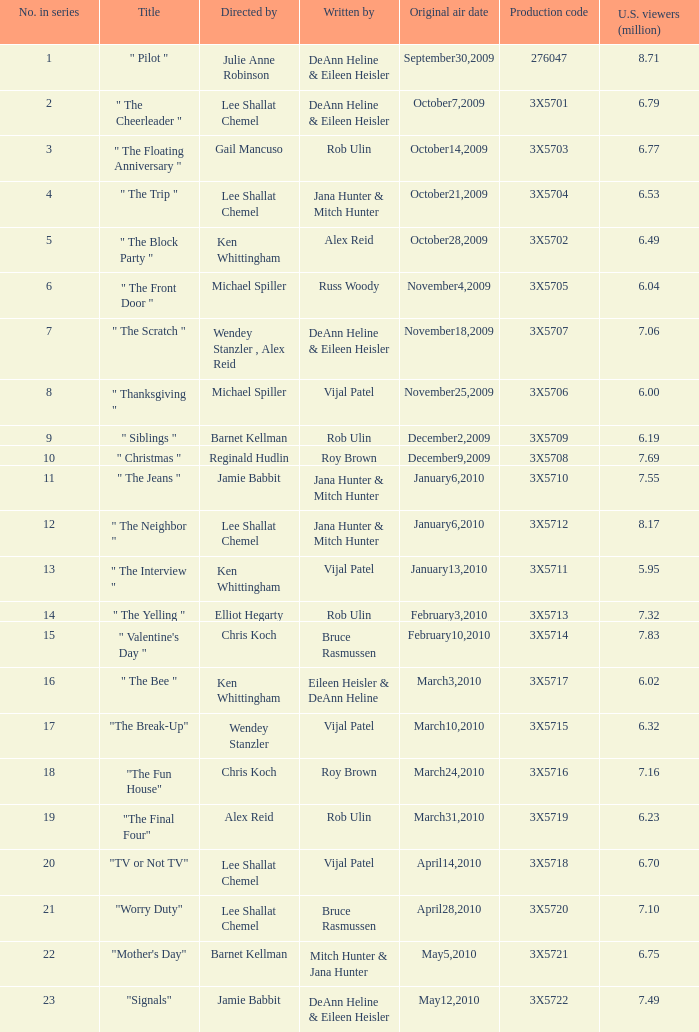How many directors got 6.79 million U.S. viewers from their episodes? 1.0. 